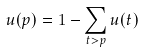Convert formula to latex. <formula><loc_0><loc_0><loc_500><loc_500>u ( p ) = 1 - \sum _ { t > p } u ( t )</formula> 